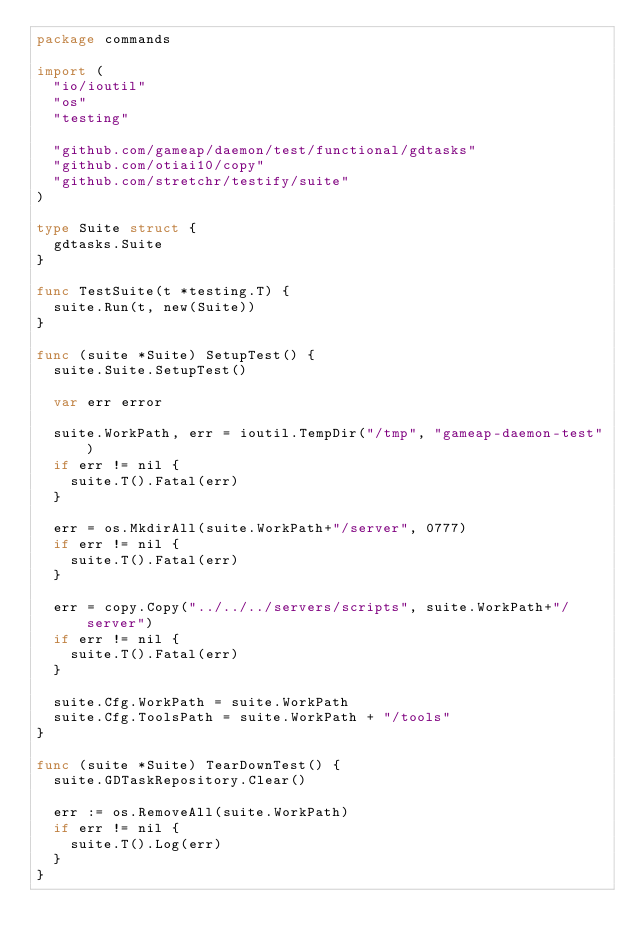<code> <loc_0><loc_0><loc_500><loc_500><_Go_>package commands

import (
	"io/ioutil"
	"os"
	"testing"

	"github.com/gameap/daemon/test/functional/gdtasks"
	"github.com/otiai10/copy"
	"github.com/stretchr/testify/suite"
)

type Suite struct {
	gdtasks.Suite
}

func TestSuite(t *testing.T) {
	suite.Run(t, new(Suite))
}

func (suite *Suite) SetupTest() {
	suite.Suite.SetupTest()

	var err error

	suite.WorkPath, err = ioutil.TempDir("/tmp", "gameap-daemon-test")
	if err != nil {
		suite.T().Fatal(err)
	}

	err = os.MkdirAll(suite.WorkPath+"/server", 0777)
	if err != nil {
		suite.T().Fatal(err)
	}

	err = copy.Copy("../../../servers/scripts", suite.WorkPath+"/server")
	if err != nil {
		suite.T().Fatal(err)
	}

	suite.Cfg.WorkPath = suite.WorkPath
	suite.Cfg.ToolsPath = suite.WorkPath + "/tools"
}

func (suite *Suite) TearDownTest() {
	suite.GDTaskRepository.Clear()

	err := os.RemoveAll(suite.WorkPath)
	if err != nil {
		suite.T().Log(err)
	}
}
</code> 